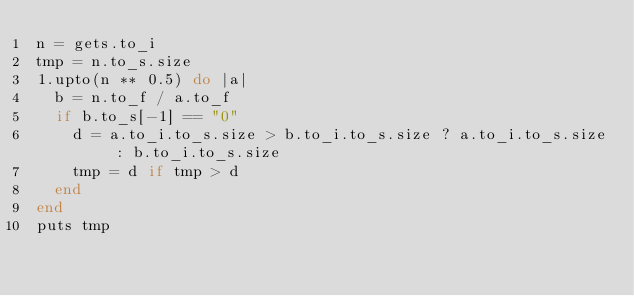Convert code to text. <code><loc_0><loc_0><loc_500><loc_500><_Ruby_>n = gets.to_i
tmp = n.to_s.size
1.upto(n ** 0.5) do |a|
  b = n.to_f / a.to_f
  if b.to_s[-1] == "0"
    d = a.to_i.to_s.size > b.to_i.to_s.size ? a.to_i.to_s.size : b.to_i.to_s.size
    tmp = d if tmp > d
  end
end
puts tmp</code> 